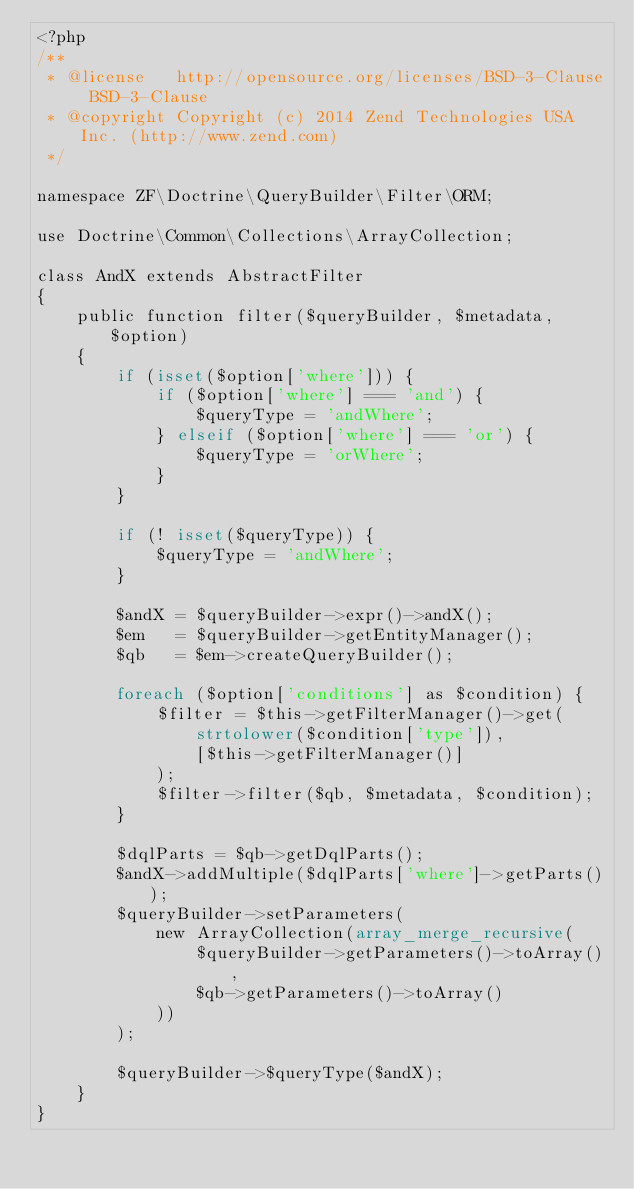Convert code to text. <code><loc_0><loc_0><loc_500><loc_500><_PHP_><?php
/**
 * @license   http://opensource.org/licenses/BSD-3-Clause BSD-3-Clause
 * @copyright Copyright (c) 2014 Zend Technologies USA Inc. (http://www.zend.com)
 */

namespace ZF\Doctrine\QueryBuilder\Filter\ORM;

use Doctrine\Common\Collections\ArrayCollection;

class AndX extends AbstractFilter
{
    public function filter($queryBuilder, $metadata, $option)
    {
        if (isset($option['where'])) {
            if ($option['where'] === 'and') {
                $queryType = 'andWhere';
            } elseif ($option['where'] === 'or') {
                $queryType = 'orWhere';
            }
        }

        if (! isset($queryType)) {
            $queryType = 'andWhere';
        }

        $andX = $queryBuilder->expr()->andX();
        $em   = $queryBuilder->getEntityManager();
        $qb   = $em->createQueryBuilder();

        foreach ($option['conditions'] as $condition) {
            $filter = $this->getFilterManager()->get(
                strtolower($condition['type']),
                [$this->getFilterManager()]
            );
            $filter->filter($qb, $metadata, $condition);
        }

        $dqlParts = $qb->getDqlParts();
        $andX->addMultiple($dqlParts['where']->getParts());
        $queryBuilder->setParameters(
            new ArrayCollection(array_merge_recursive(
                $queryBuilder->getParameters()->toArray(),
                $qb->getParameters()->toArray()
            ))
        );

        $queryBuilder->$queryType($andX);
    }
}
</code> 